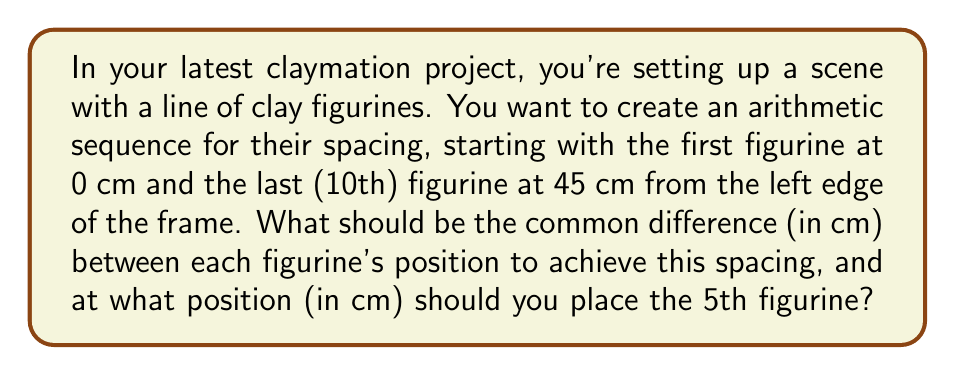Help me with this question. Let's approach this step-by-step:

1) In an arithmetic sequence, the difference between each term is constant. Let's call this common difference $d$.

2) We know the first term $a_1 = 0$ cm and the last (10th) term $a_{10} = 45$ cm.

3) The formula for the nth term of an arithmetic sequence is:
   $a_n = a_1 + (n-1)d$

4) Applying this to our last term:
   $45 = 0 + (10-1)d$
   $45 = 9d$

5) Solving for $d$:
   $d = 45 / 9 = 5$ cm

6) Now that we know the common difference, we can find the position of the 5th figurine using the same formula:
   $a_5 = a_1 + (5-1)d$
   $a_5 = 0 + (4)(5)$
   $a_5 = 20$ cm

Therefore, the common difference is 5 cm, and the 5th figurine should be placed at 20 cm from the left edge of the frame.
Answer: $d = 5$ cm, $a_5 = 20$ cm 